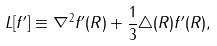<formula> <loc_0><loc_0><loc_500><loc_500>L [ f ^ { \prime } ] \equiv \nabla ^ { 2 } f ^ { \prime } ( R ) + \frac { 1 } { 3 } \triangle ( R ) f ^ { \prime } ( R ) ,</formula> 